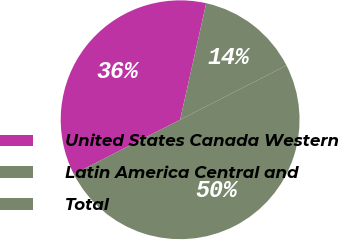Convert chart. <chart><loc_0><loc_0><loc_500><loc_500><pie_chart><fcel>United States Canada Western<fcel>Latin America Central and<fcel>Total<nl><fcel>36.03%<fcel>13.97%<fcel>50.0%<nl></chart> 